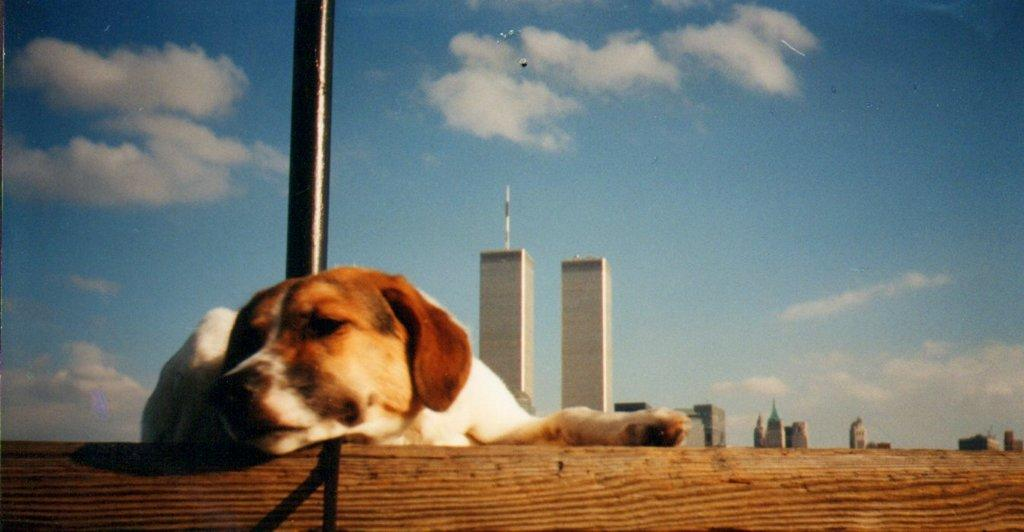What animal can be seen on the wall on the left side of the image? There is a dog on a wall on the left side of the image. What is beside the dog on the wall? There is a black color pole beside the dog. What can be seen in the distance in the image? There are buildings in the background of the image. What is the color of the sky in the background of the image? The sky in the background of the image is blue, and there are clouds visible. What type of battle is taking place in the image? There is no battle present in the image; it features a dog on a wall with a black pole beside it, buildings in the background, and a blue sky with clouds. What chess piece is represented by the dog on the wall? The image does not depict a chess piece; it is a dog on a wall with a black pole beside it, buildings in the background, and a blue sky with clouds. 